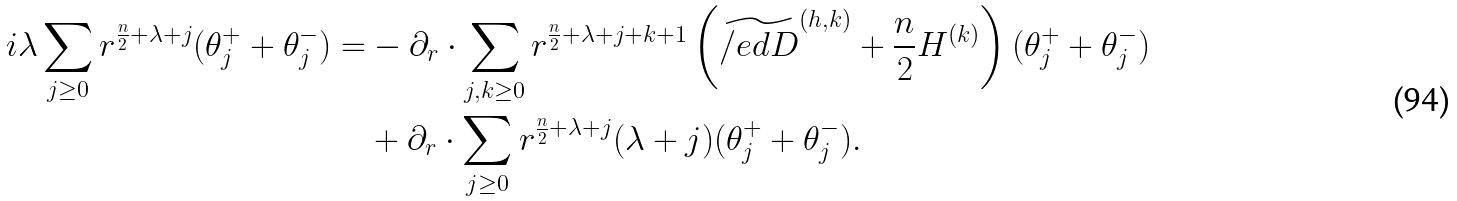Convert formula to latex. <formula><loc_0><loc_0><loc_500><loc_500>i \lambda \sum _ { j \geq 0 } r ^ { \frac { n } { 2 } + \lambda + j } ( \theta _ { j } ^ { + } + \theta ^ { - } _ { j } ) = & - \partial _ { r } \cdot \sum _ { j , k \geq 0 } r ^ { \frac { n } { 2 } + \lambda + j + k + 1 } \left ( \widetilde { \slash e d { D } } ^ { ( h , k ) } + \frac { n } { 2 } H ^ { ( k ) } \right ) ( \theta ^ { + } _ { j } + \theta ^ { - } _ { j } ) \\ & + \partial _ { r } \cdot \sum _ { j \geq 0 } r ^ { \frac { n } { 2 } + \lambda + j } ( \lambda + j ) ( \theta ^ { + } _ { j } + \theta ^ { - } _ { j } ) .</formula> 